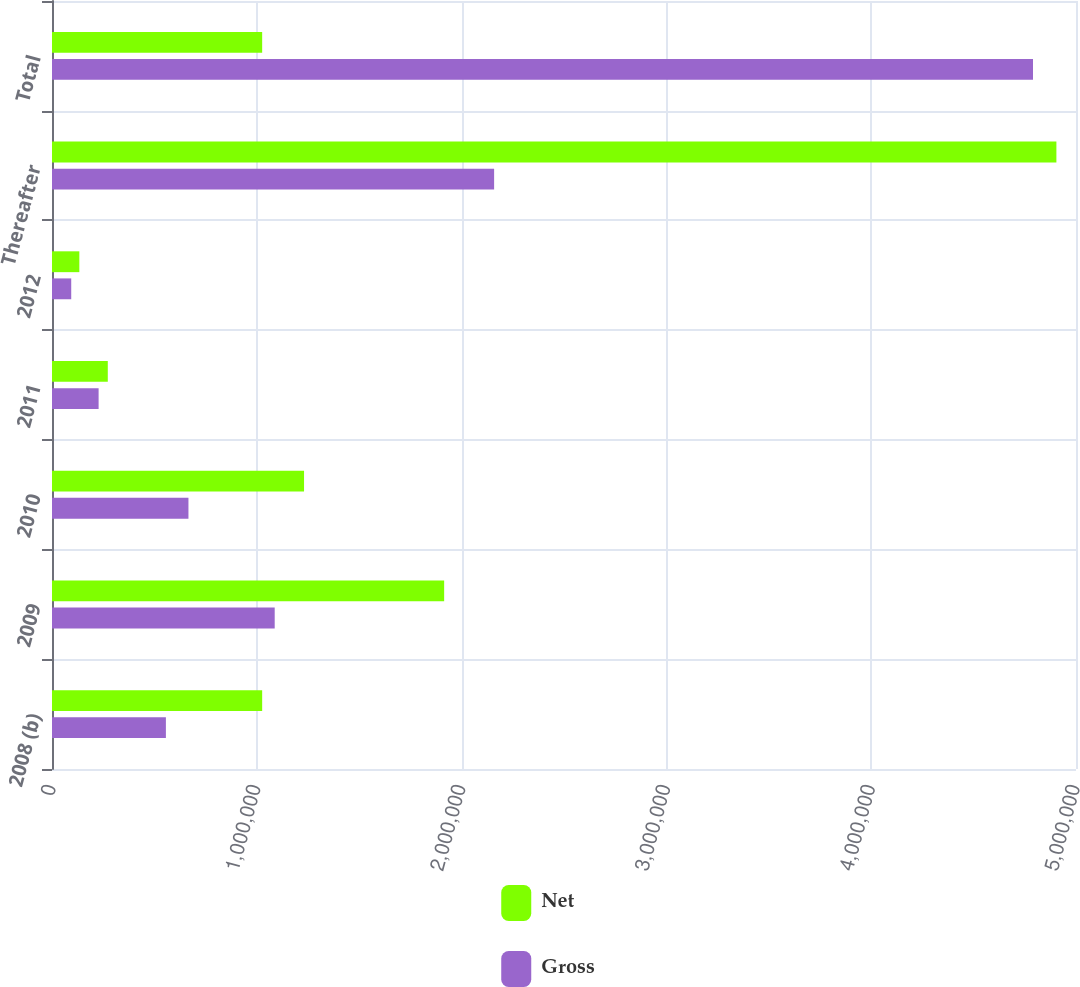Convert chart. <chart><loc_0><loc_0><loc_500><loc_500><stacked_bar_chart><ecel><fcel>2008 (b)<fcel>2009<fcel>2010<fcel>2011<fcel>2012<fcel>Thereafter<fcel>Total<nl><fcel>Net<fcel>1.0262e+06<fcel>1.91482e+06<fcel>1.23069e+06<fcel>272400<fcel>133499<fcel>4.90431e+06<fcel>1.0262e+06<nl><fcel>Gross<fcel>556110<fcel>1.0874e+06<fcel>666252<fcel>227596<fcel>93894<fcel>2.15877e+06<fcel>4.79003e+06<nl></chart> 